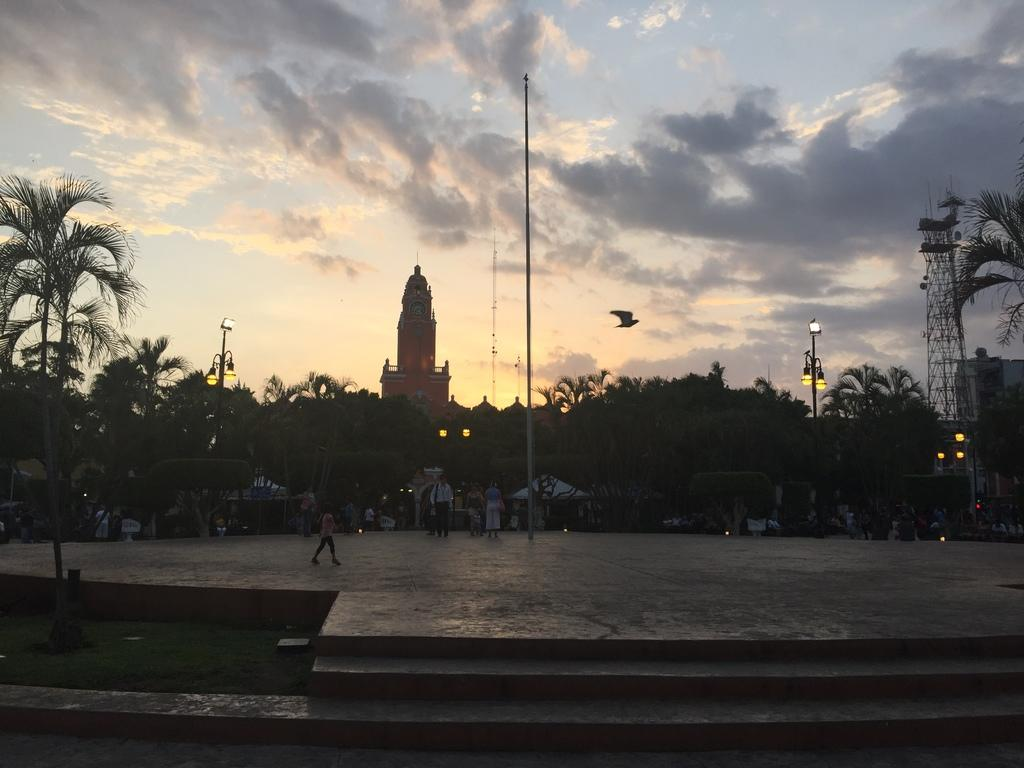What is in the foreground of the image? There is a pavement in the foreground of the image. What can be seen on the pavement? There are people on the pavement. What is around the pavement? There are lights and trees around the pavement. What is visible in the background of the image? There is a clock tower in the background of the image. What type of battle is taking place in the image? There is no battle present in the image; it features a pavement with people, lights, trees, and a clock tower in the background. What type of shame is depicted in the image? There is no shame depicted in the image; it is a neutral scene featuring a pavement, people, lights, trees, and a clock tower. 